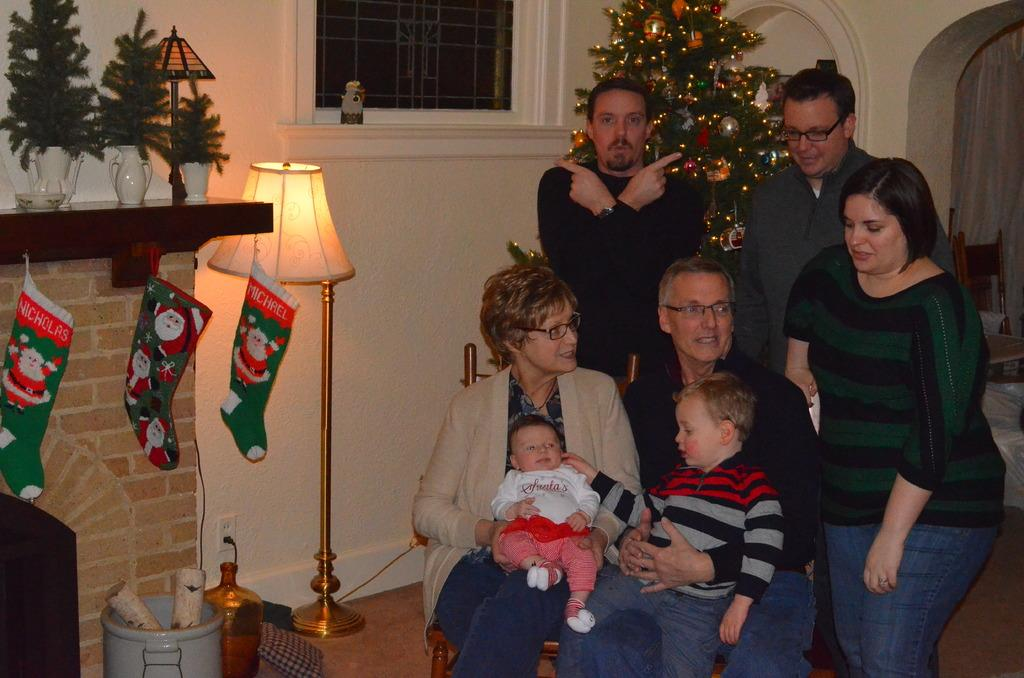How many people are in the image? There are persons in the image, but the exact number cannot be determined from the provided facts. What object in the image provides light? There is a lamp in the image that provides light. What is the purpose of the water tin in the image? The purpose of the water tin in the image is not specified, but it might be used for holding water. What type of decorations are present in the image? There are banners and a Christmas tree in the image, which are both decorative items. What type of container is used for holding flowers in the image? There are flower vases in the image that are used for holding flowers. What can be seen through the window in the image? The facts do not specify what can be seen through the window in the image. What is the background of the image? There is a wall in the background of the image, and a chair is also visible in the background. What type of pie is being served in the image? There is no mention of a pie in the image or the provided facts. What time of day is it in the image? The facts do not specify the time of day in the image, but it could be any time. 